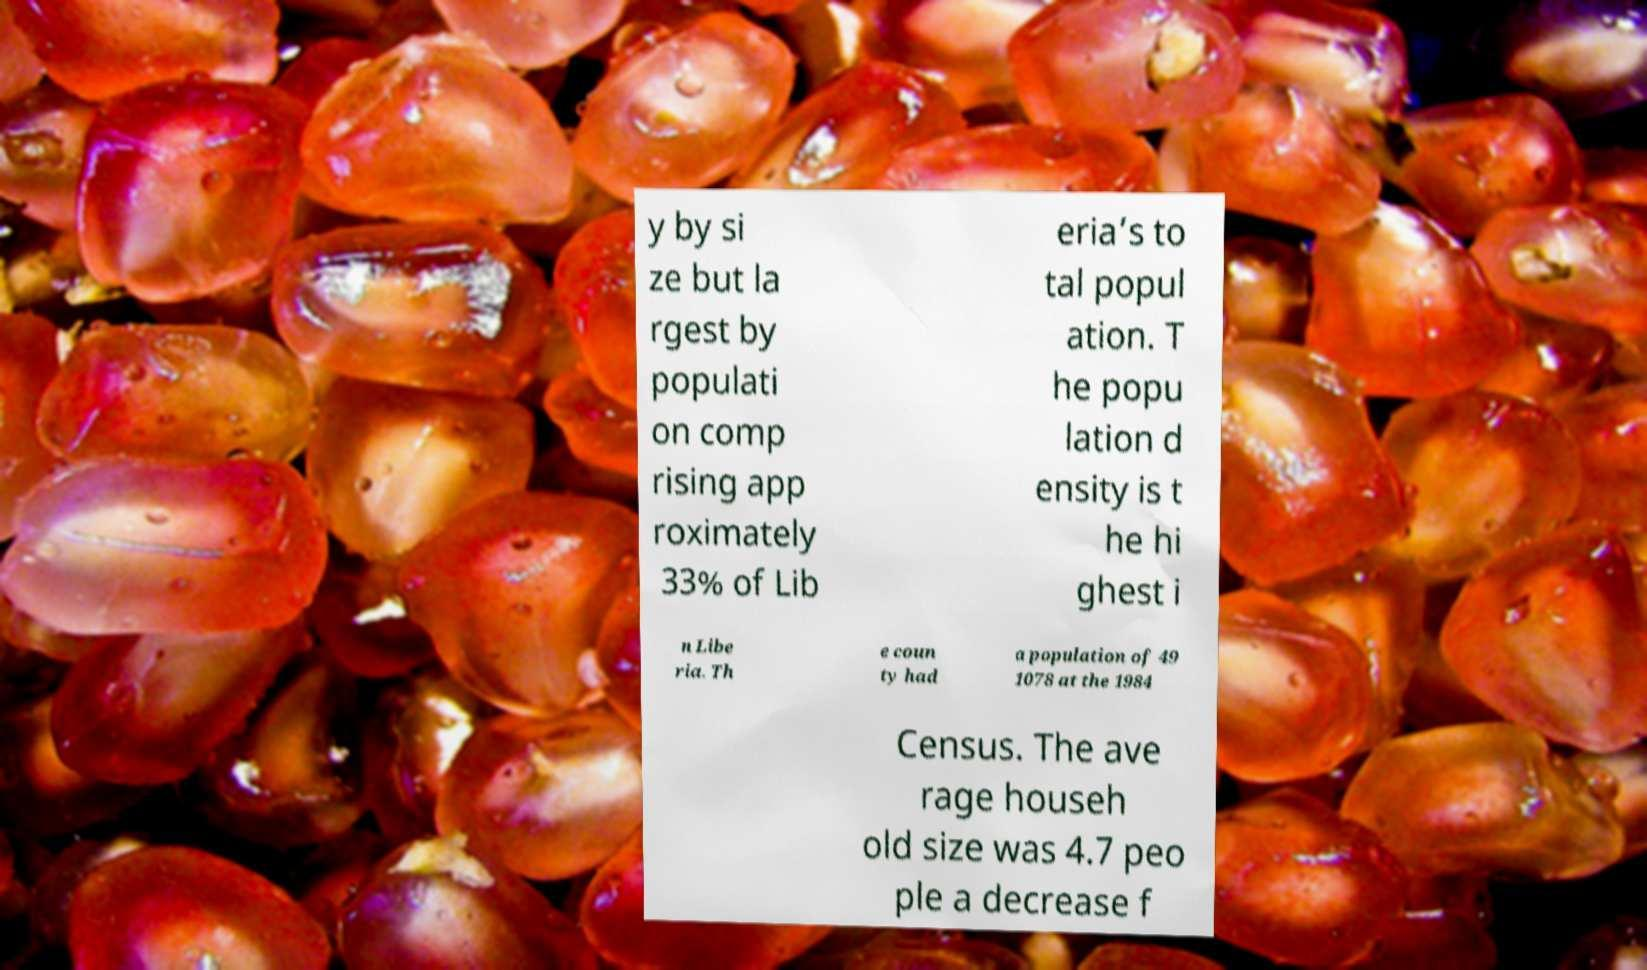Please read and relay the text visible in this image. What does it say? y by si ze but la rgest by populati on comp rising app roximately 33% of Lib eria’s to tal popul ation. T he popu lation d ensity is t he hi ghest i n Libe ria. Th e coun ty had a population of 49 1078 at the 1984 Census. The ave rage househ old size was 4.7 peo ple a decrease f 